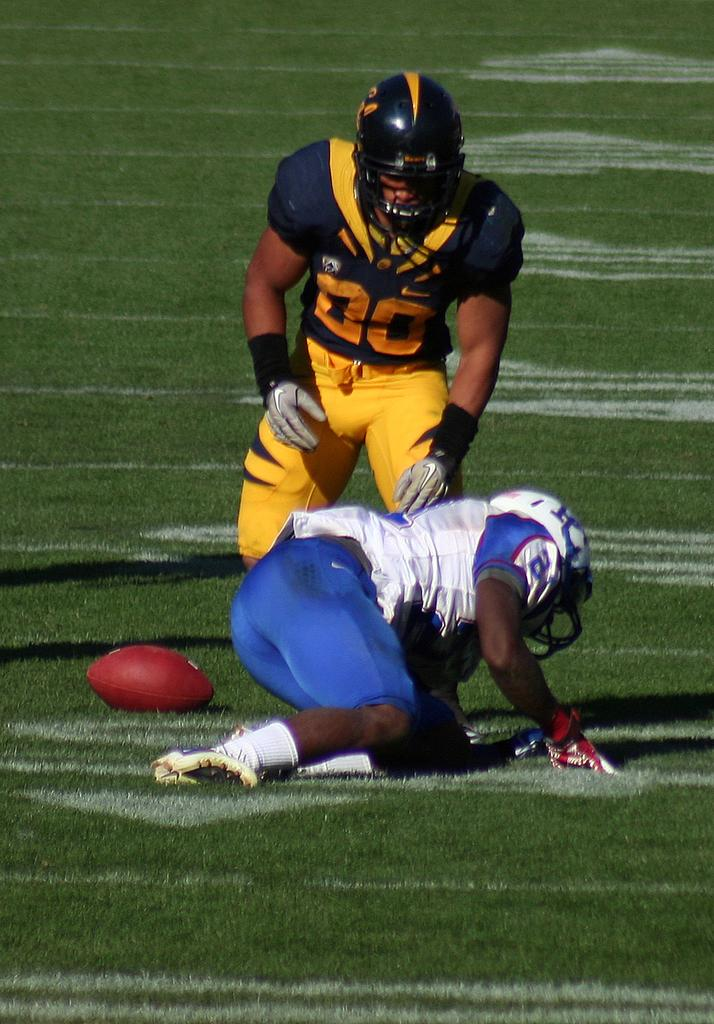How many players are in the image? There are two players in the image. What is the condition of the first player? The first player is falling on the ground. What is the condition of the second player? The second player is standing. What object is beside the players on the ground? There is a ball beside the players on the ground. Where is the kitten playing with chalk in the image? There is no kitten or chalk present in the image. What is the name of the downtown street where the players are located in the image? The image does not provide information about the location of the players or the presence of a downtown street. 